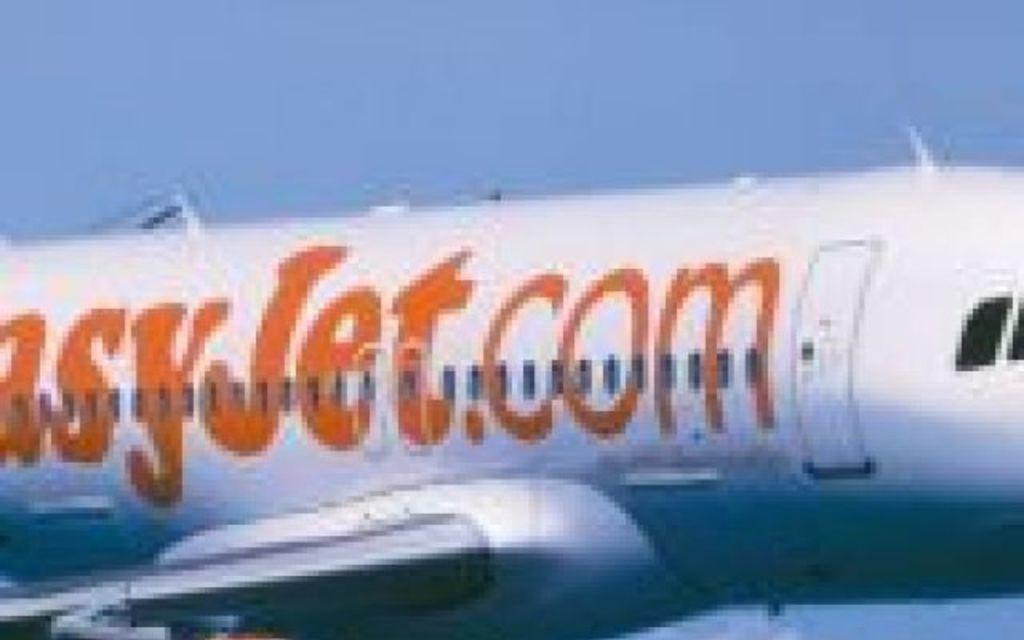Please provide a concise description of this image. In the image we can see an airplane and these are the windows of the airplane, this is a sky. 